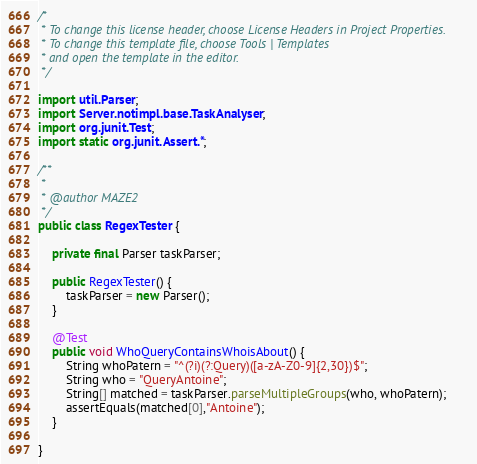<code> <loc_0><loc_0><loc_500><loc_500><_Java_>/*
 * To change this license header, choose License Headers in Project Properties.
 * To change this template file, choose Tools | Templates
 * and open the template in the editor.
 */

import util.Parser;
import Server.notimpl.base.TaskAnalyser;
import org.junit.Test;
import static org.junit.Assert.*;

/**
 *
 * @author MAZE2
 */
public class RegexTester {

    private final Parser taskParser;

    public RegexTester() {
        taskParser = new Parser();
    }

    @Test
    public void WhoQueryContainsWhoisAbout() {
        String whoPatern = "^(?i)(?:Query)([a-zA-Z0-9]{2,30})$";
        String who = "QueryAntoine";
        String[] matched = taskParser.parseMultipleGroups(who, whoPatern);
        assertEquals(matched[0],"Antoine");
    }

}
</code> 